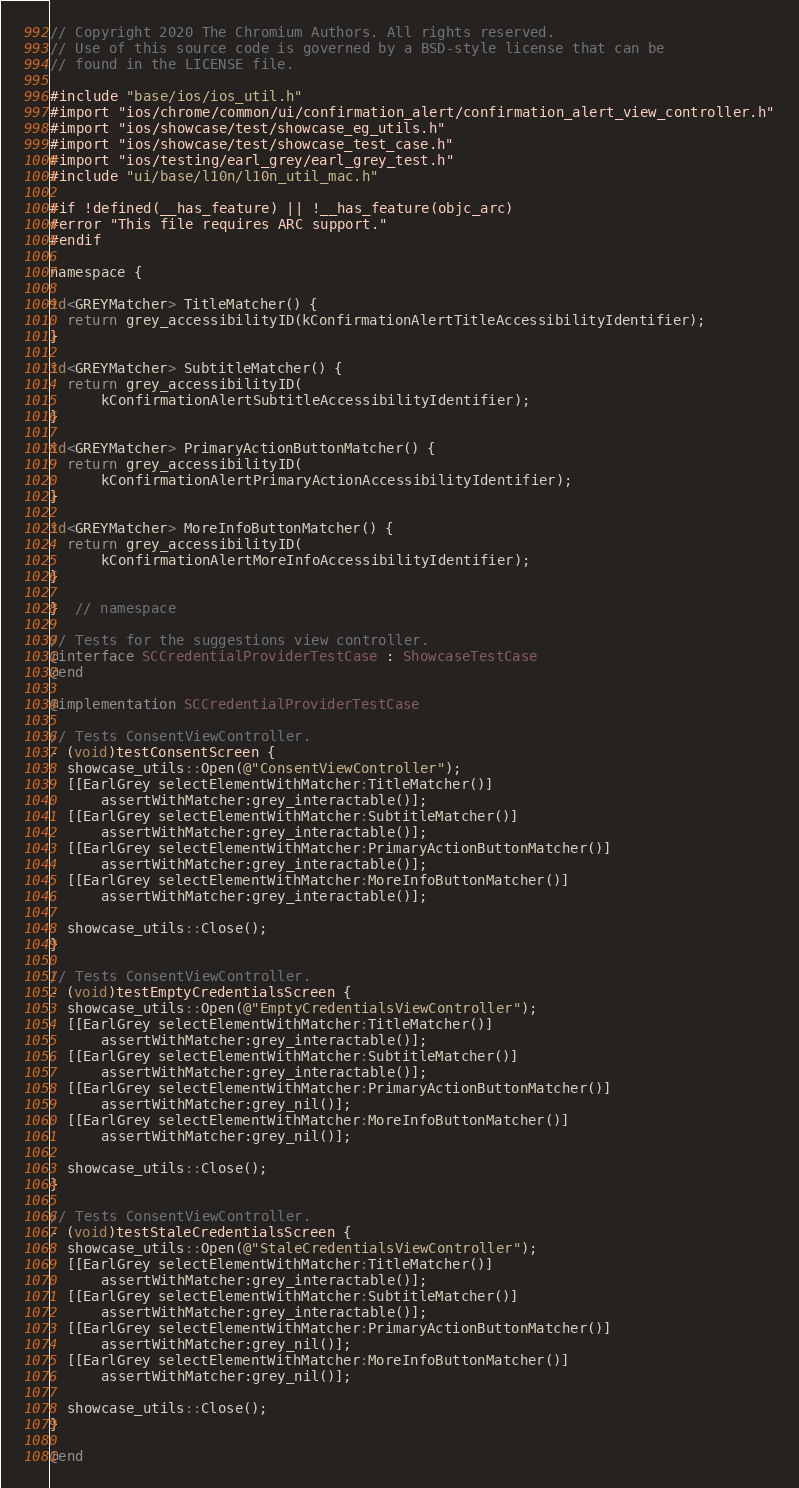<code> <loc_0><loc_0><loc_500><loc_500><_ObjectiveC_>// Copyright 2020 The Chromium Authors. All rights reserved.
// Use of this source code is governed by a BSD-style license that can be
// found in the LICENSE file.

#include "base/ios/ios_util.h"
#import "ios/chrome/common/ui/confirmation_alert/confirmation_alert_view_controller.h"
#import "ios/showcase/test/showcase_eg_utils.h"
#import "ios/showcase/test/showcase_test_case.h"
#import "ios/testing/earl_grey/earl_grey_test.h"
#include "ui/base/l10n/l10n_util_mac.h"

#if !defined(__has_feature) || !__has_feature(objc_arc)
#error "This file requires ARC support."
#endif

namespace {

id<GREYMatcher> TitleMatcher() {
  return grey_accessibilityID(kConfirmationAlertTitleAccessibilityIdentifier);
}

id<GREYMatcher> SubtitleMatcher() {
  return grey_accessibilityID(
      kConfirmationAlertSubtitleAccessibilityIdentifier);
}

id<GREYMatcher> PrimaryActionButtonMatcher() {
  return grey_accessibilityID(
      kConfirmationAlertPrimaryActionAccessibilityIdentifier);
}

id<GREYMatcher> MoreInfoButtonMatcher() {
  return grey_accessibilityID(
      kConfirmationAlertMoreInfoAccessibilityIdentifier);
}

}  // namespace

// Tests for the suggestions view controller.
@interface SCCredentialProviderTestCase : ShowcaseTestCase
@end

@implementation SCCredentialProviderTestCase

// Tests ConsentViewController.
- (void)testConsentScreen {
  showcase_utils::Open(@"ConsentViewController");
  [[EarlGrey selectElementWithMatcher:TitleMatcher()]
      assertWithMatcher:grey_interactable()];
  [[EarlGrey selectElementWithMatcher:SubtitleMatcher()]
      assertWithMatcher:grey_interactable()];
  [[EarlGrey selectElementWithMatcher:PrimaryActionButtonMatcher()]
      assertWithMatcher:grey_interactable()];
  [[EarlGrey selectElementWithMatcher:MoreInfoButtonMatcher()]
      assertWithMatcher:grey_interactable()];

  showcase_utils::Close();
}

// Tests ConsentViewController.
- (void)testEmptyCredentialsScreen {
  showcase_utils::Open(@"EmptyCredentialsViewController");
  [[EarlGrey selectElementWithMatcher:TitleMatcher()]
      assertWithMatcher:grey_interactable()];
  [[EarlGrey selectElementWithMatcher:SubtitleMatcher()]
      assertWithMatcher:grey_interactable()];
  [[EarlGrey selectElementWithMatcher:PrimaryActionButtonMatcher()]
      assertWithMatcher:grey_nil()];
  [[EarlGrey selectElementWithMatcher:MoreInfoButtonMatcher()]
      assertWithMatcher:grey_nil()];

  showcase_utils::Close();
}

// Tests ConsentViewController.
- (void)testStaleCredentialsScreen {
  showcase_utils::Open(@"StaleCredentialsViewController");
  [[EarlGrey selectElementWithMatcher:TitleMatcher()]
      assertWithMatcher:grey_interactable()];
  [[EarlGrey selectElementWithMatcher:SubtitleMatcher()]
      assertWithMatcher:grey_interactable()];
  [[EarlGrey selectElementWithMatcher:PrimaryActionButtonMatcher()]
      assertWithMatcher:grey_nil()];
  [[EarlGrey selectElementWithMatcher:MoreInfoButtonMatcher()]
      assertWithMatcher:grey_nil()];

  showcase_utils::Close();
}

@end
</code> 